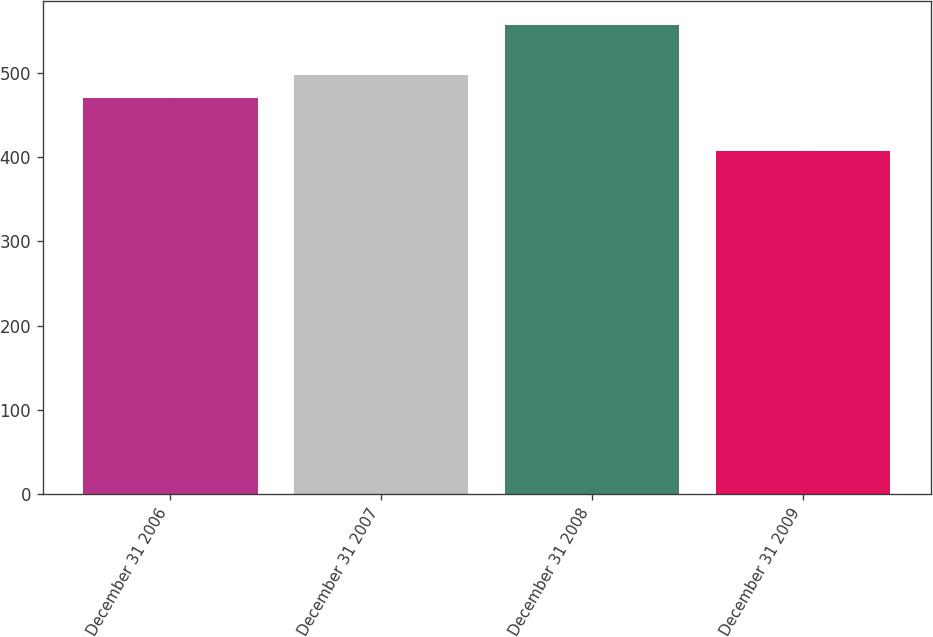Convert chart. <chart><loc_0><loc_0><loc_500><loc_500><bar_chart><fcel>December 31 2006<fcel>December 31 2007<fcel>December 31 2008<fcel>December 31 2009<nl><fcel>470<fcel>497<fcel>557<fcel>407<nl></chart> 